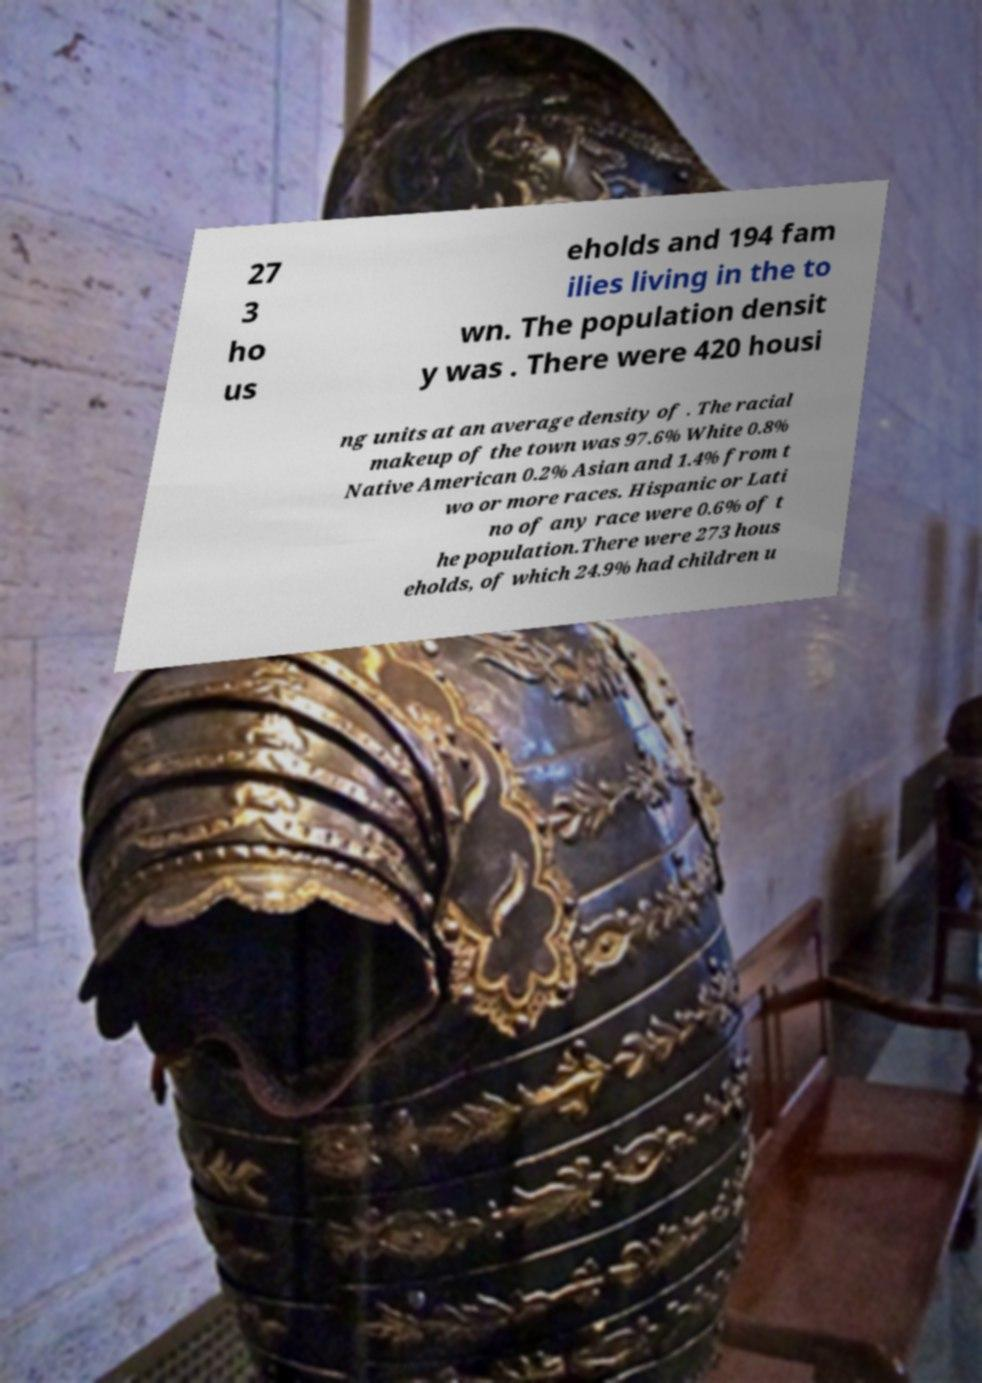Please identify and transcribe the text found in this image. 27 3 ho us eholds and 194 fam ilies living in the to wn. The population densit y was . There were 420 housi ng units at an average density of . The racial makeup of the town was 97.6% White 0.8% Native American 0.2% Asian and 1.4% from t wo or more races. Hispanic or Lati no of any race were 0.6% of t he population.There were 273 hous eholds, of which 24.9% had children u 